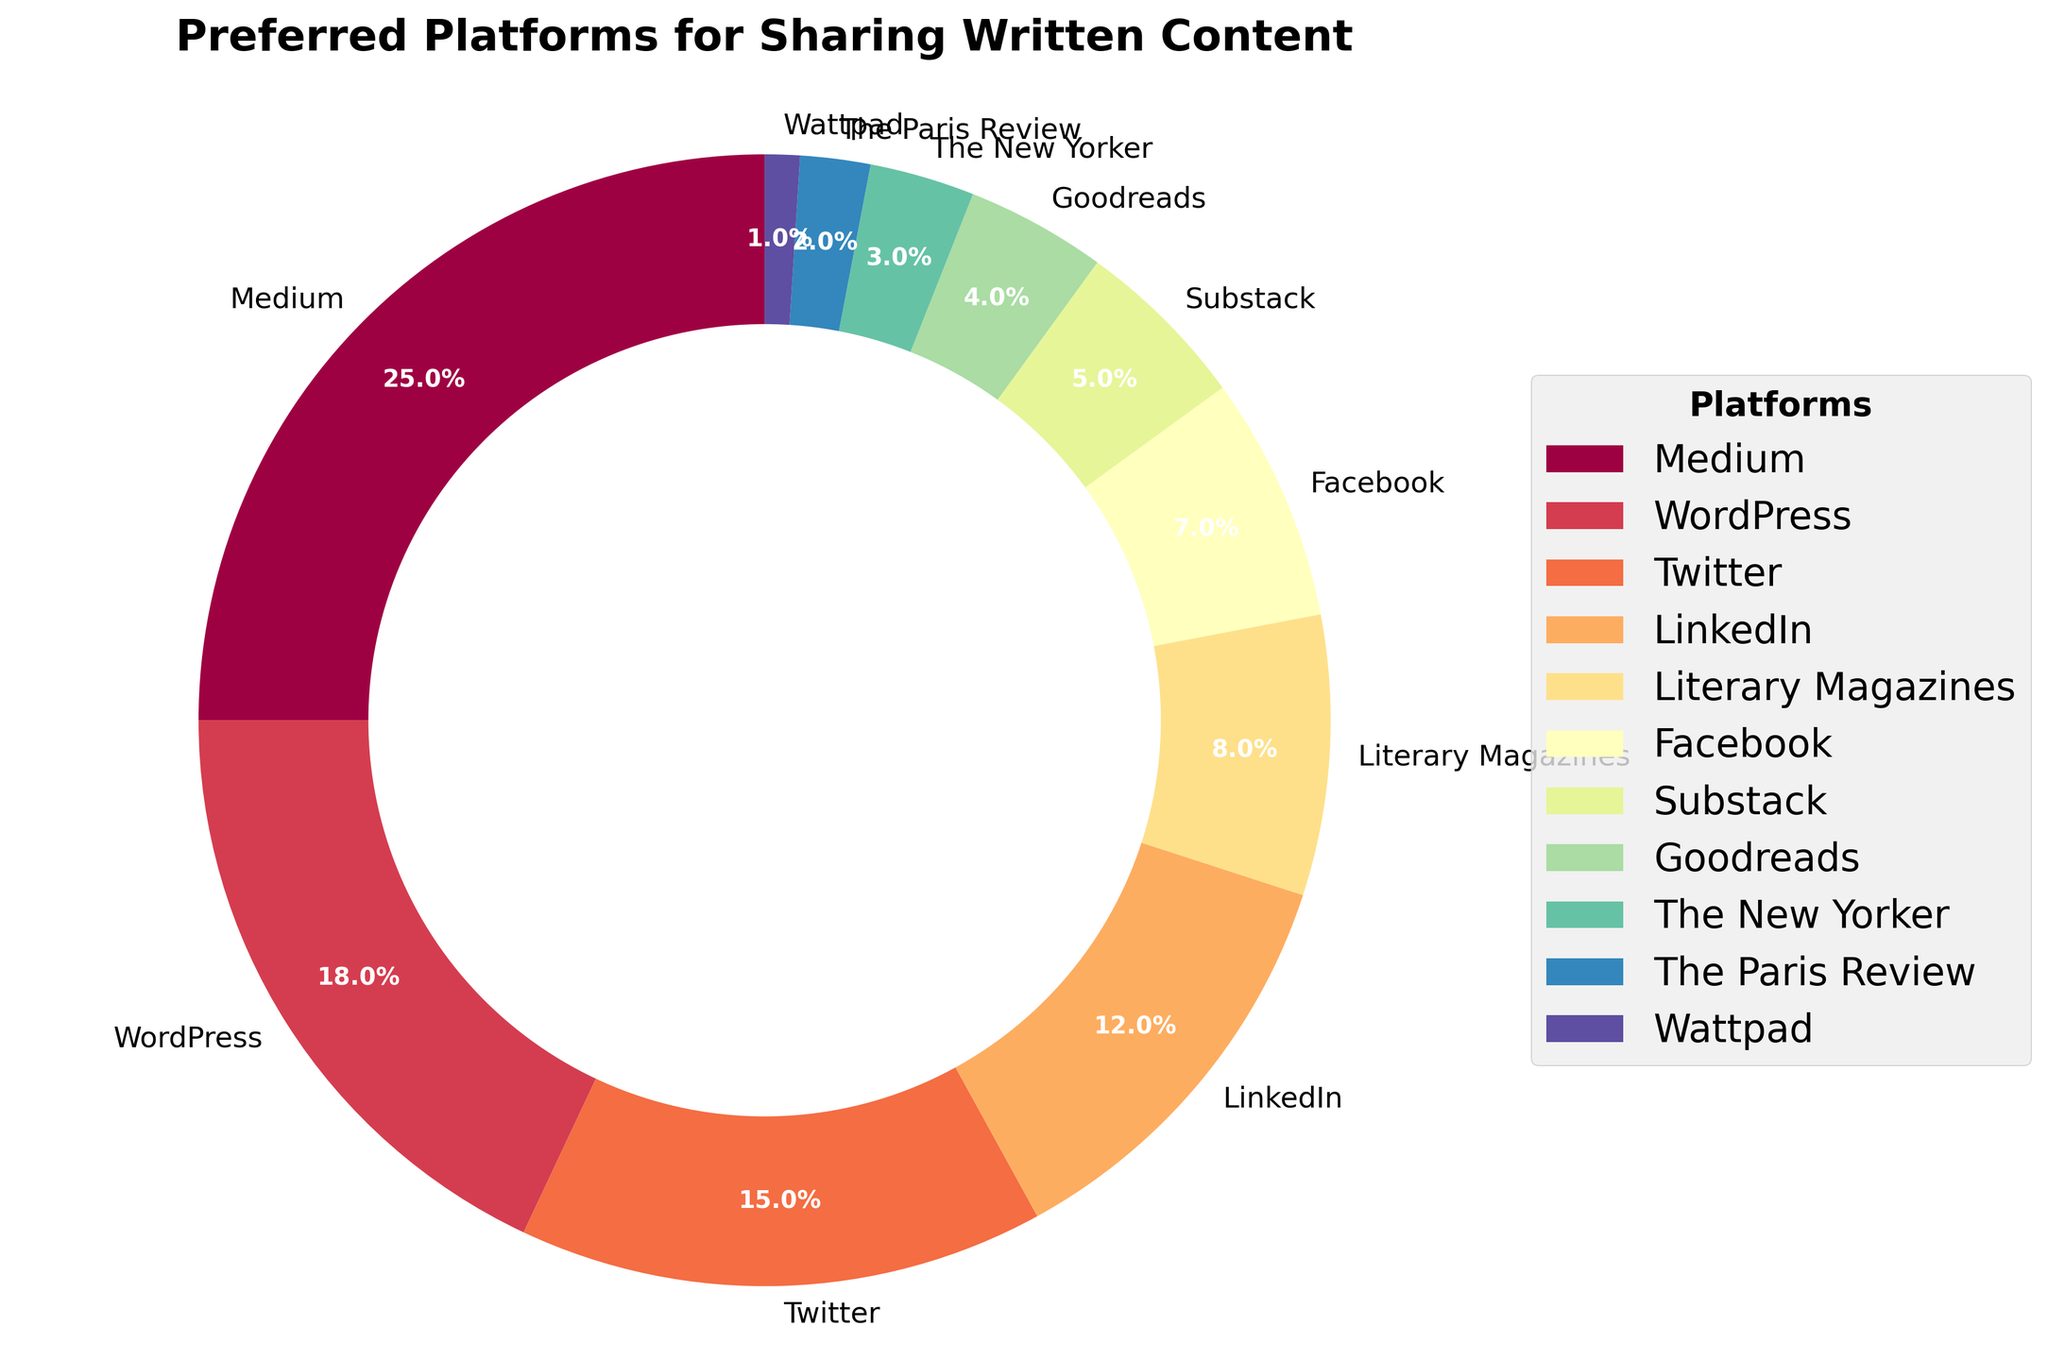What percentage of users prefer Medium over WordPress? The percentages for Medium and WordPress are 25% and 18%, respectively. Subtract the percentage for WordPress from Medium: 25% - 18% = 7%
Answer: 7% Which platform has the lowest percentage preference? The platform with the smallest percentage is Wattpad with 1%
Answer: Wattpad Combine the percentages for LinkedIn, Facebook, and Substack. What is the total? LinkedIn has 12%, Facebook has 7%, and Substack has 5%. Summing these gives: 12% + 7% + 5% = 24%
Answer: 24% What is the difference in percentage points between the two most preferred platforms? The two highest percentages are Medium at 25% and WordPress at 18%. The difference is: 25% - 18% = 7%
Answer: 7% Which platforms have a combined preference equal to or greater than 20%? Medium (25%), WordPress (18%), Twitter (15%), LinkedIn (12%), and Literary Magazines (8%) individually make up at least 20%. Combining any two or more percentages such as LinkedIn (12%) + Facebook (7%) + Substack (5%) = 24% also meets the condition
Answer: Medium, WordPress, Twitter, LinkedIn, Literary Magazines, and Combined (LinkedIn + Facebook + Substack) How do the preferences for literary magazines compare to traditional publications like The New Yorker and The Paris Review? Literary Magazines are at 8%, while The New Yorker is at 3% and The Paris Review is at 2%. So, 8% > 3% + 2%
Answer: Literary Magazines > The New Yorker + The Paris Review Is the combined preference for social media platforms (Twitter, LinkedIn, Facebook) higher than blog platforms (Medium, WordPress, Substack)? Social media total: Twitter (15%) + LinkedIn (12%) + Facebook (7%) = 34%. Blog platforms total: Medium (25%) + WordPress (18%) + Substack (5%) = 48%. 34% < 48%
Answer: No What is the average preference percentage for all the listed platforms? Sum of all percentages: 25 + 18 + 15 + 12 + 8 + 7 + 5 + 4 + 3 + 2 + 1 = 100%. Number of platforms: 11. Average is 100% / 11 = 9.1%
Answer: 9.1% Based on visual elements, which platform's wedge has a distinctive color while still being prominent in size? Medium's wedge has a distinctive color owing to its largest share of 25%. This size makes it prominent.
Answer: Medium Does Substack or Goodreads have a larger preference share? Substack has 5% while Goodreads has 4%, thus Substack has a larger share
Answer: Substack 